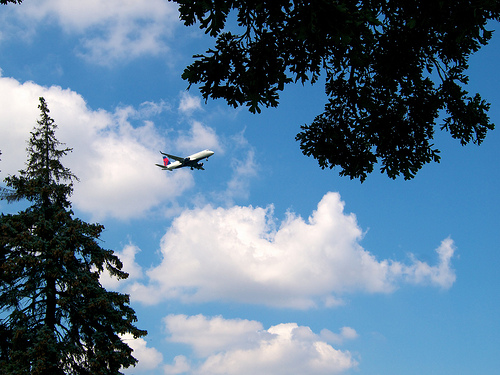What season could it be judging by the trees? The lush green leaves on the trees suggest that it is likely spring or summer. 